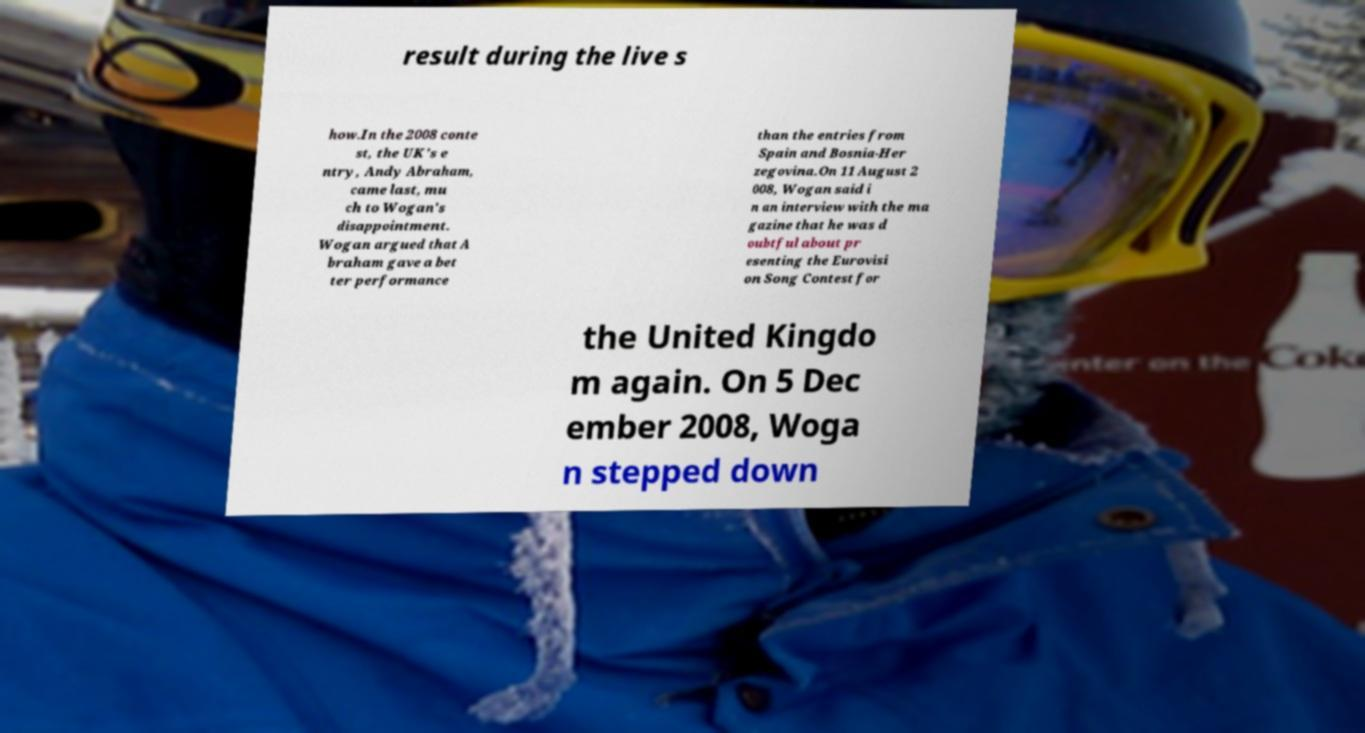Could you extract and type out the text from this image? result during the live s how.In the 2008 conte st, the UK's e ntry, Andy Abraham, came last, mu ch to Wogan's disappointment. Wogan argued that A braham gave a bet ter performance than the entries from Spain and Bosnia-Her zegovina.On 11 August 2 008, Wogan said i n an interview with the ma gazine that he was d oubtful about pr esenting the Eurovisi on Song Contest for the United Kingdo m again. On 5 Dec ember 2008, Woga n stepped down 